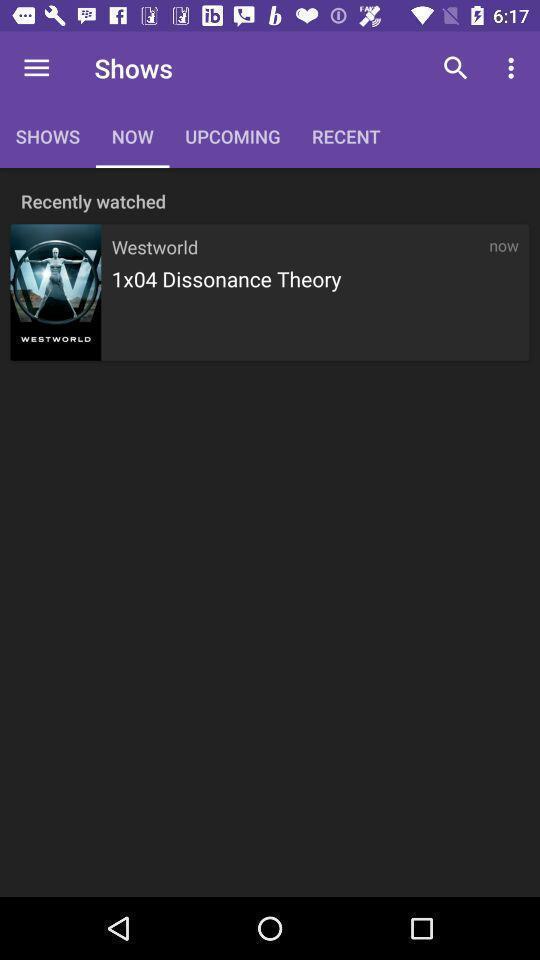Give me a narrative description of this picture. Page showing list of shows. 